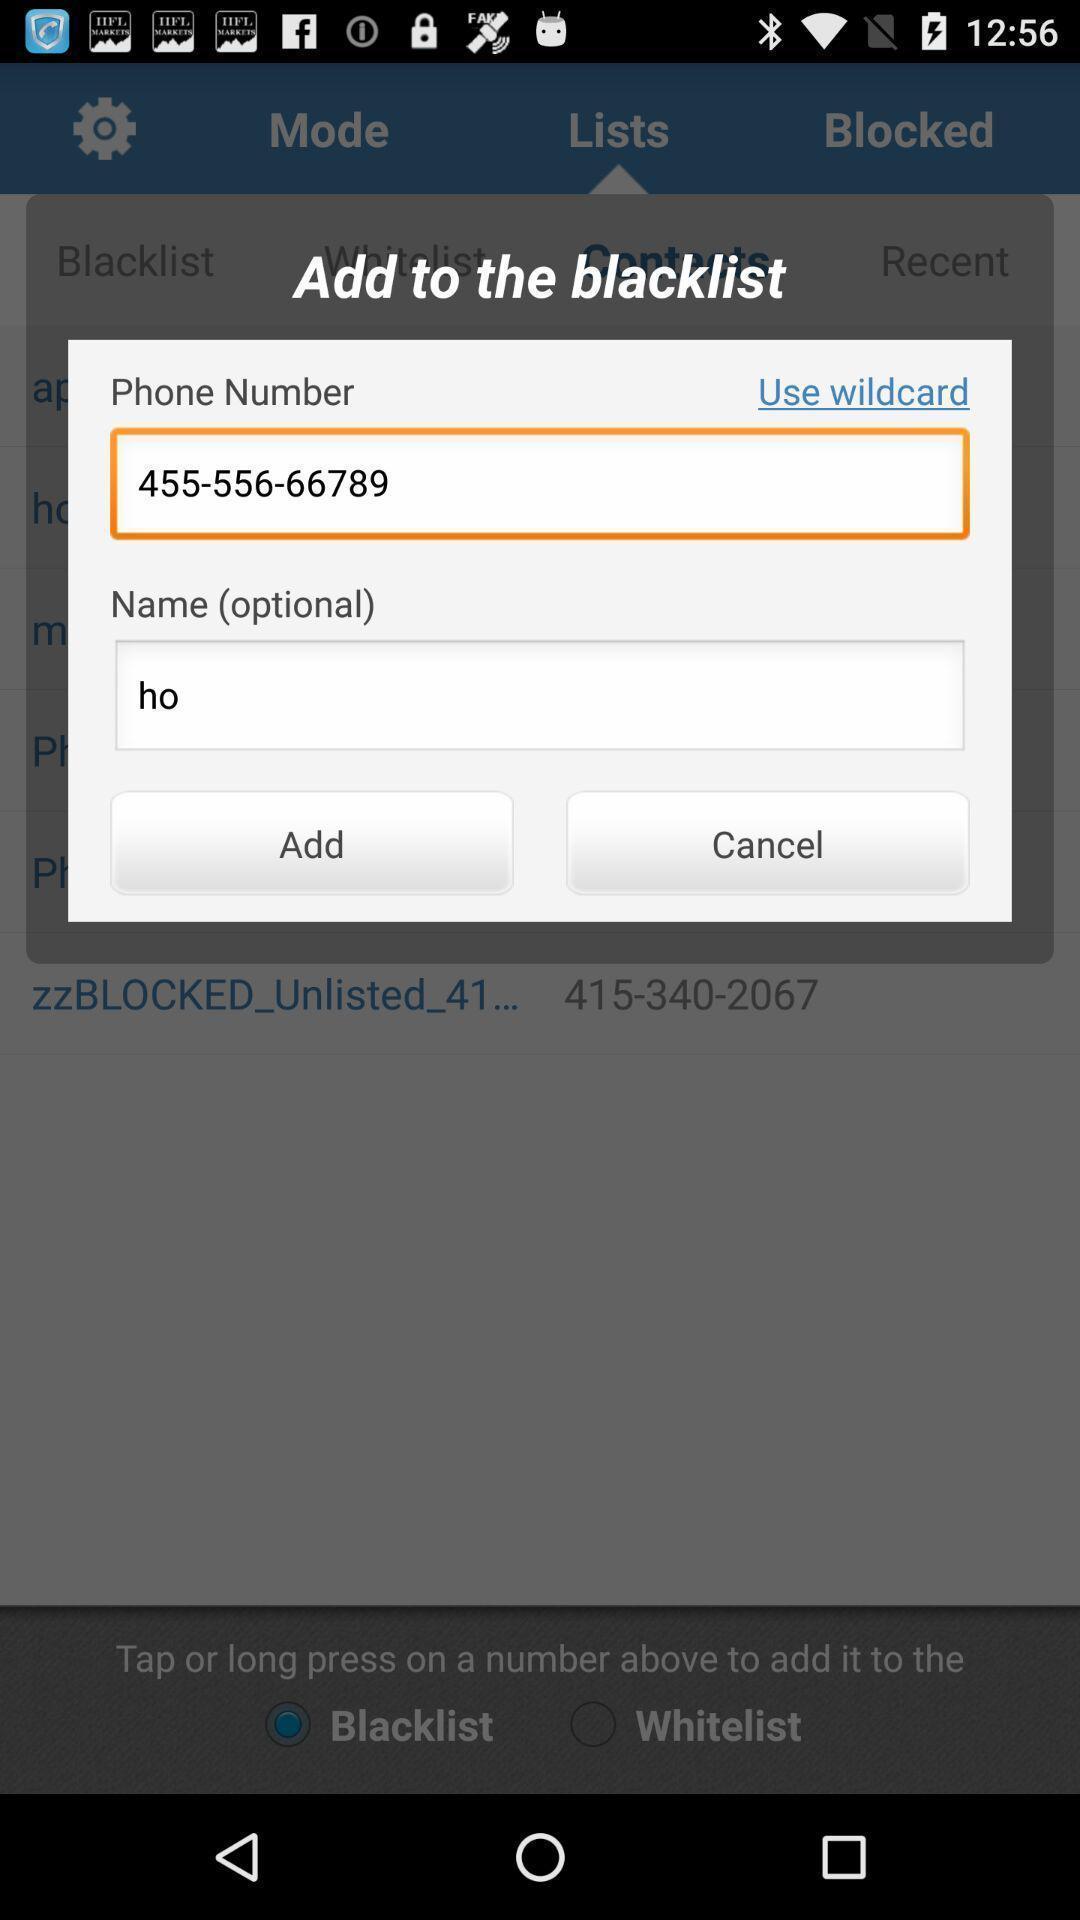Explain what's happening in this screen capture. Popup of tab to enter the phone number in application. 